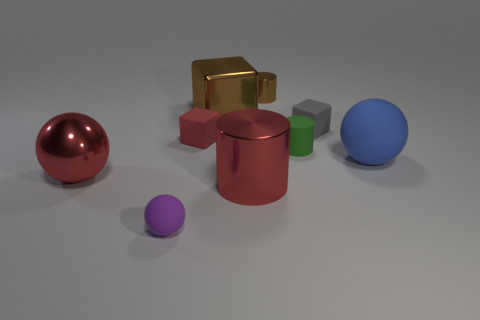What size is the cylinder in front of the big blue thing? The cylinder in front of the large blue sphere appears to be medium-sized, relative to the other objects in the image. It is smaller than the blue sphere but larger than the small purple sphere near it. 